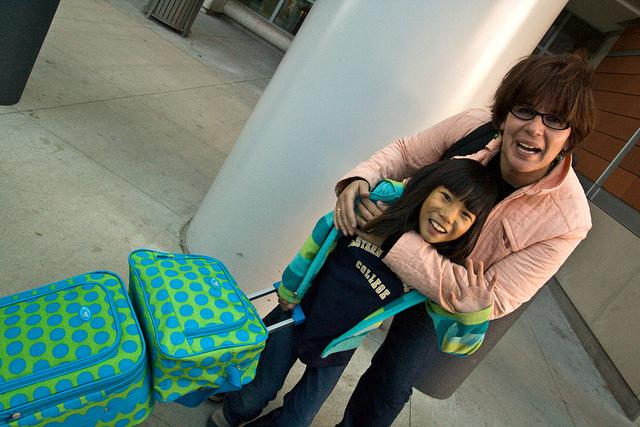Why is the young girl holding luggage? Please explain your reasoning. to travel. Luggage is used for traveling. the luggage looks new and is likely used for traveling. 